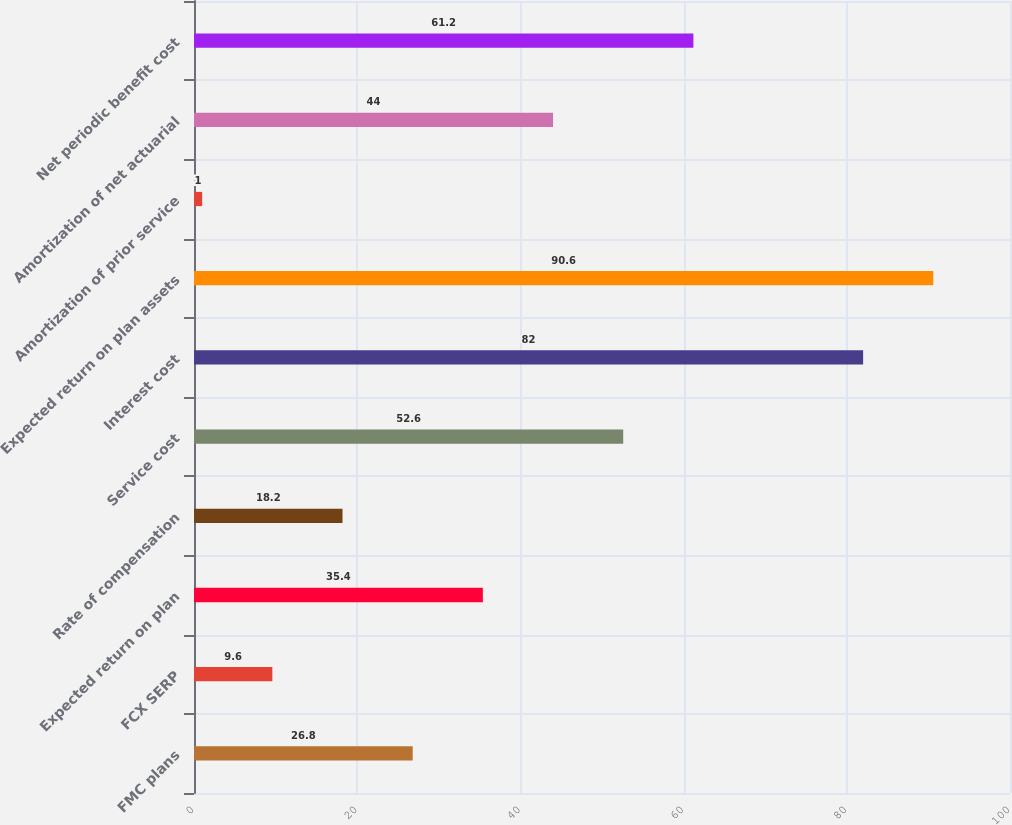<chart> <loc_0><loc_0><loc_500><loc_500><bar_chart><fcel>FMC plans<fcel>FCX SERP<fcel>Expected return on plan<fcel>Rate of compensation<fcel>Service cost<fcel>Interest cost<fcel>Expected return on plan assets<fcel>Amortization of prior service<fcel>Amortization of net actuarial<fcel>Net periodic benefit cost<nl><fcel>26.8<fcel>9.6<fcel>35.4<fcel>18.2<fcel>52.6<fcel>82<fcel>90.6<fcel>1<fcel>44<fcel>61.2<nl></chart> 